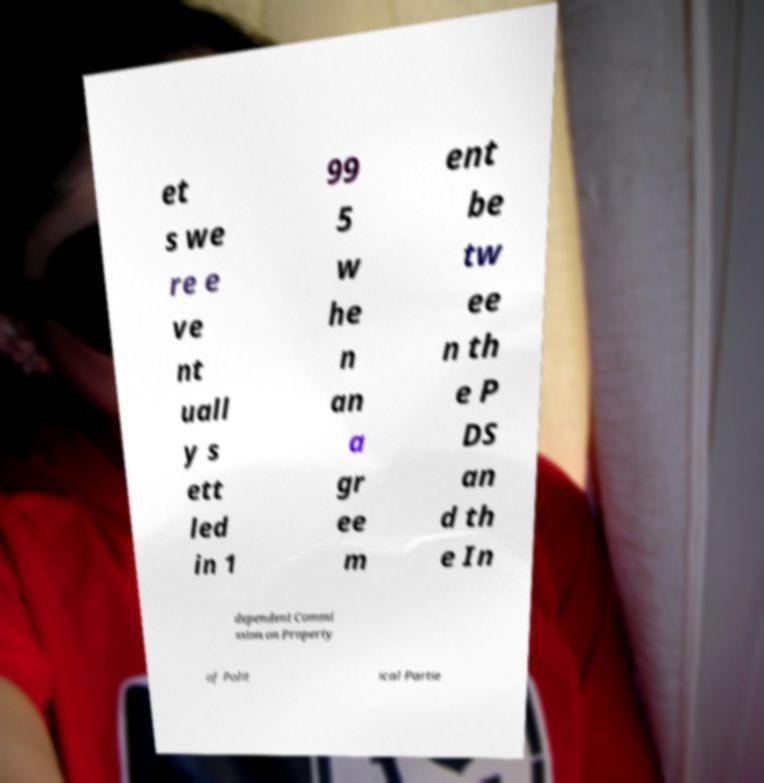There's text embedded in this image that I need extracted. Can you transcribe it verbatim? et s we re e ve nt uall y s ett led in 1 99 5 w he n an a gr ee m ent be tw ee n th e P DS an d th e In dependent Commi ssion on Property of Polit ical Partie 